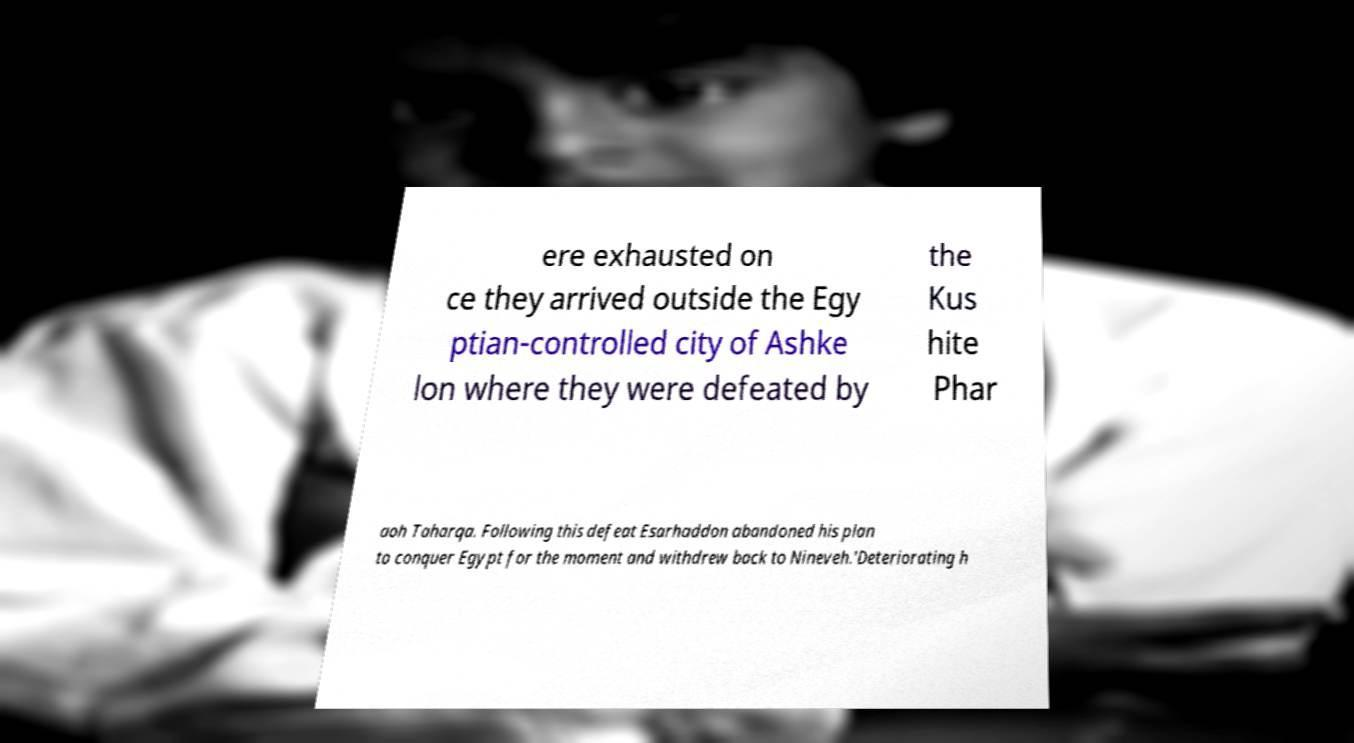There's text embedded in this image that I need extracted. Can you transcribe it verbatim? ere exhausted on ce they arrived outside the Egy ptian-controlled city of Ashke lon where they were defeated by the Kus hite Phar aoh Taharqa. Following this defeat Esarhaddon abandoned his plan to conquer Egypt for the moment and withdrew back to Nineveh.'Deteriorating h 